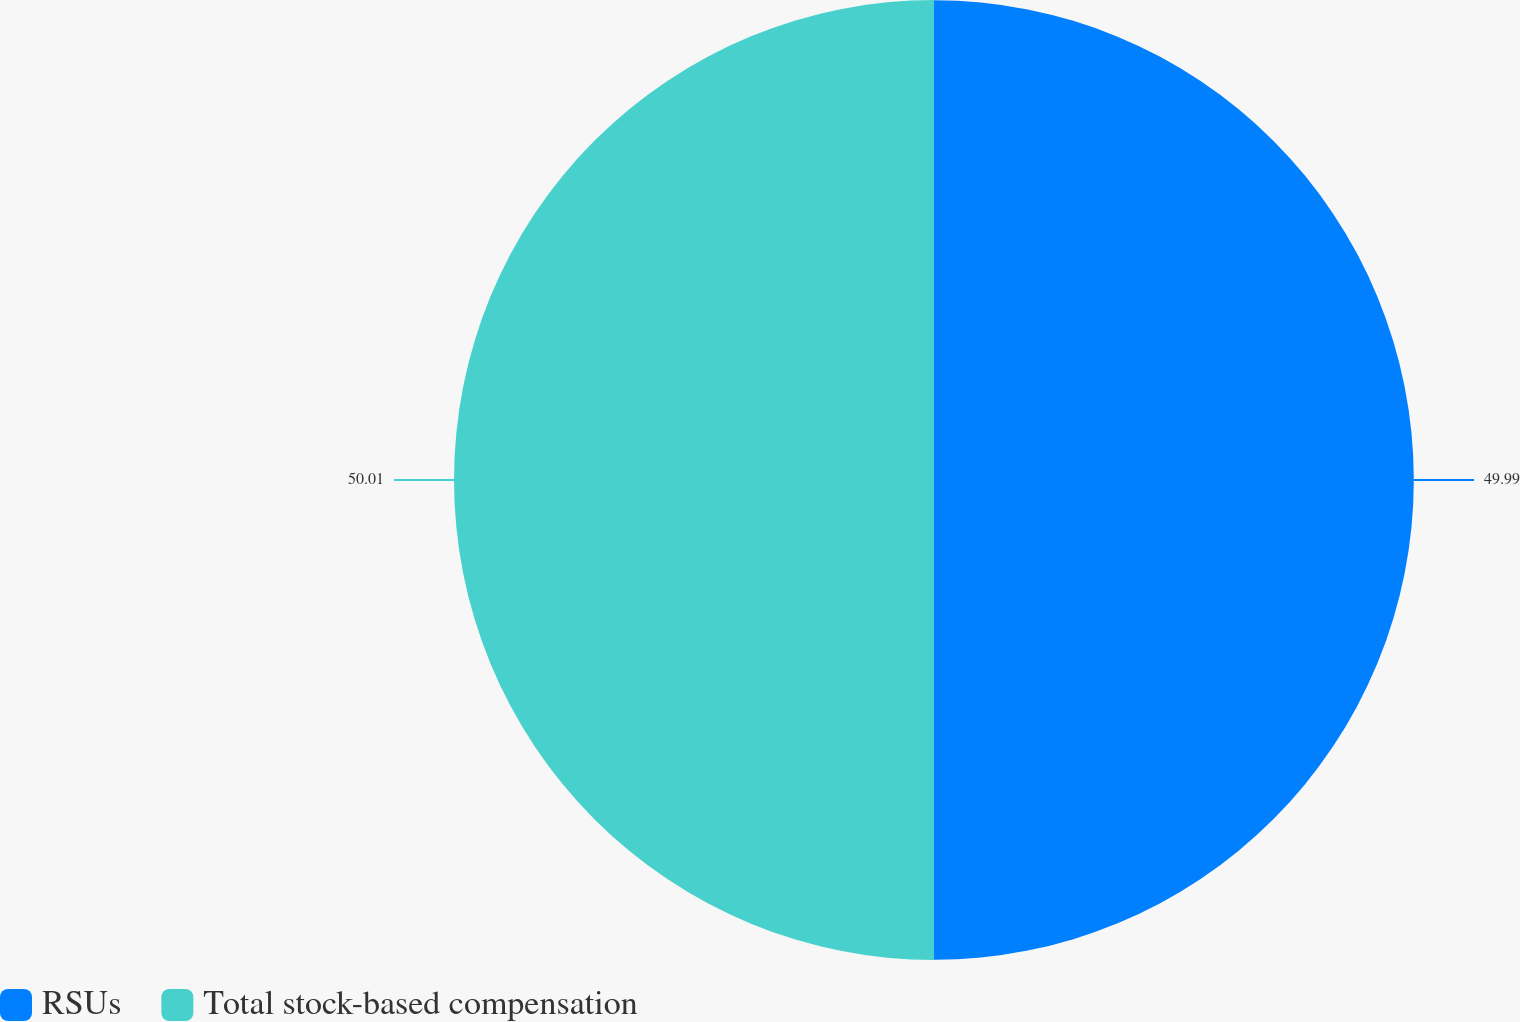Convert chart. <chart><loc_0><loc_0><loc_500><loc_500><pie_chart><fcel>RSUs<fcel>Total stock-based compensation<nl><fcel>49.99%<fcel>50.01%<nl></chart> 